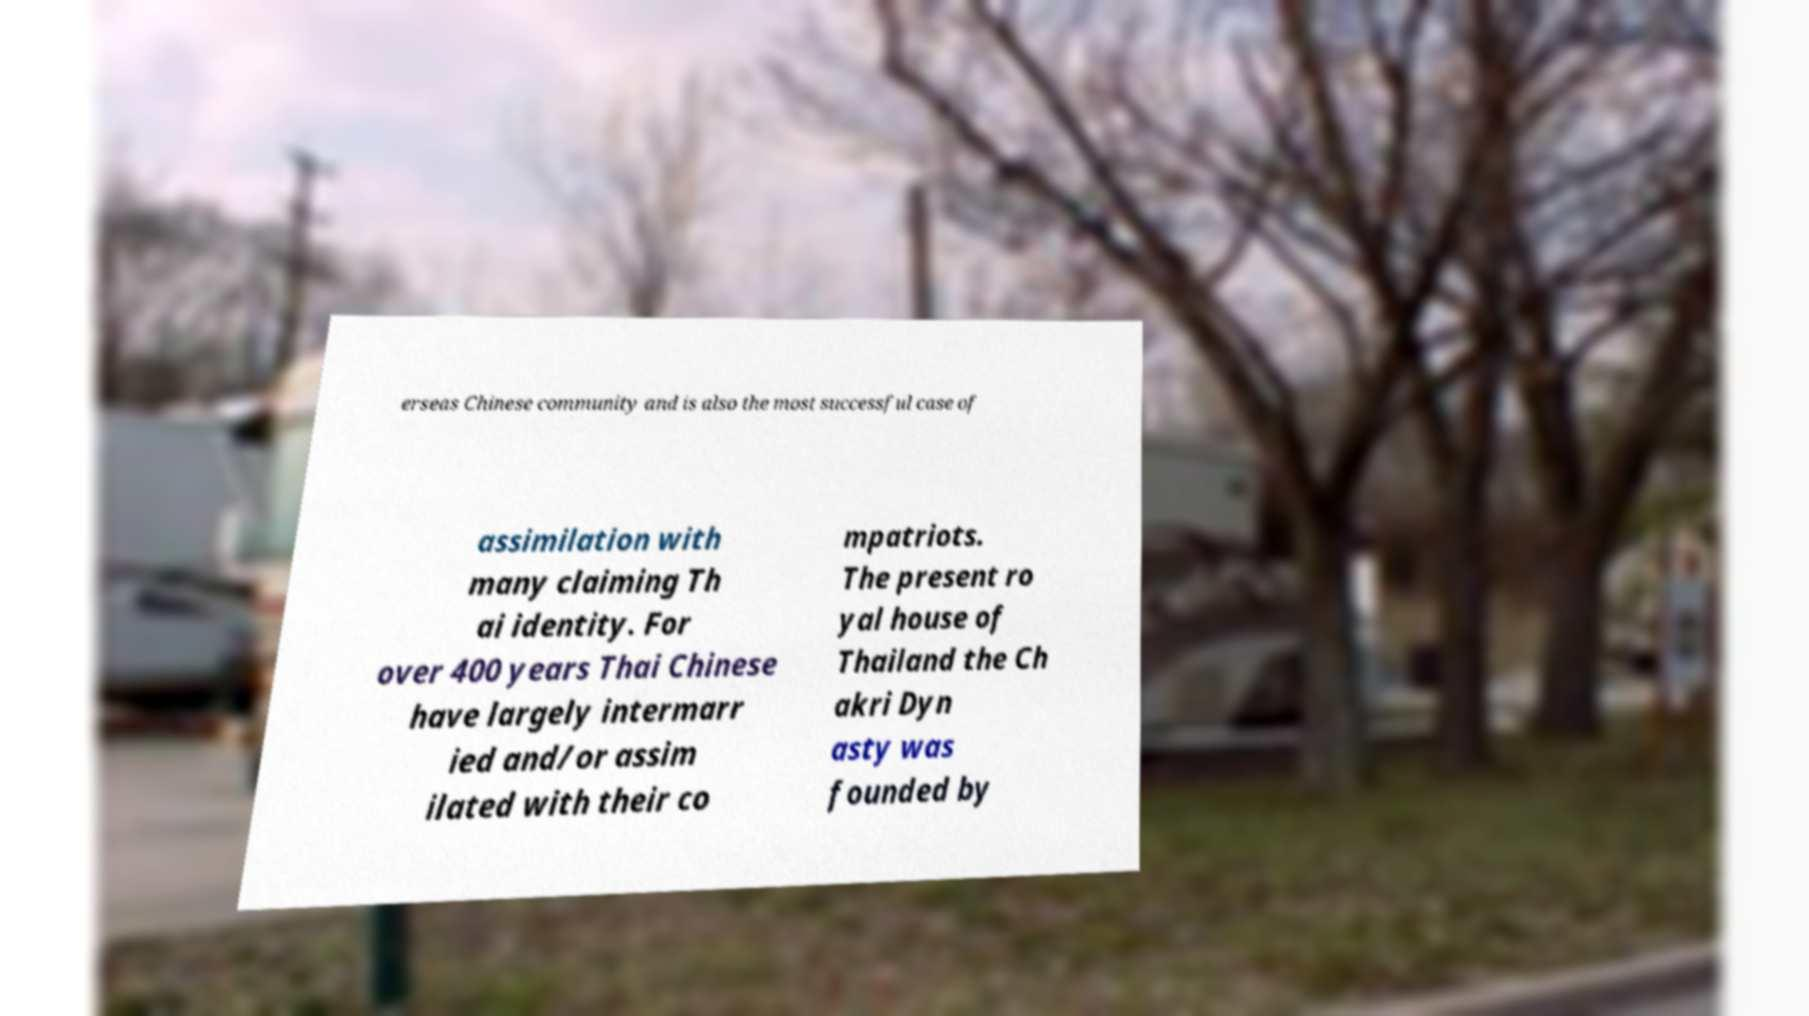I need the written content from this picture converted into text. Can you do that? erseas Chinese community and is also the most successful case of assimilation with many claiming Th ai identity. For over 400 years Thai Chinese have largely intermarr ied and/or assim ilated with their co mpatriots. The present ro yal house of Thailand the Ch akri Dyn asty was founded by 